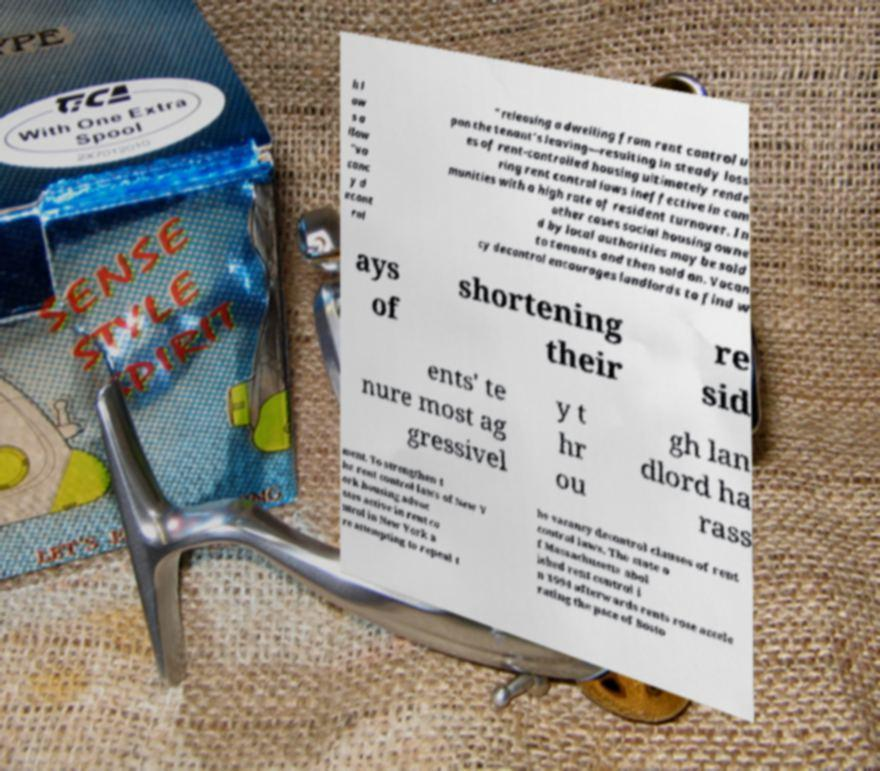What messages or text are displayed in this image? I need them in a readable, typed format. h l aw s a llow "va canc y d econt rol " releasing a dwelling from rent control u pon the tenant's leaving—resulting in steady loss es of rent-controlled housing ultimately rende ring rent control laws ineffective in com munities with a high rate of resident turnover. In other cases social housing owne d by local authorities may be sold to tenants and then sold on. Vacan cy decontrol encourages landlords to find w ays of shortening their re sid ents' te nure most ag gressivel y t hr ou gh lan dlord ha rass ment. To strengthen t he rent control laws of New Y ork housing advoc ates active in rent co ntrol in New York a re attempting to repeal t he vacancy decontrol clauses of rent control laws. The state o f Massachusetts abol ished rent control i n 1994 afterwards rents rose accele rating the pace of Bosto 